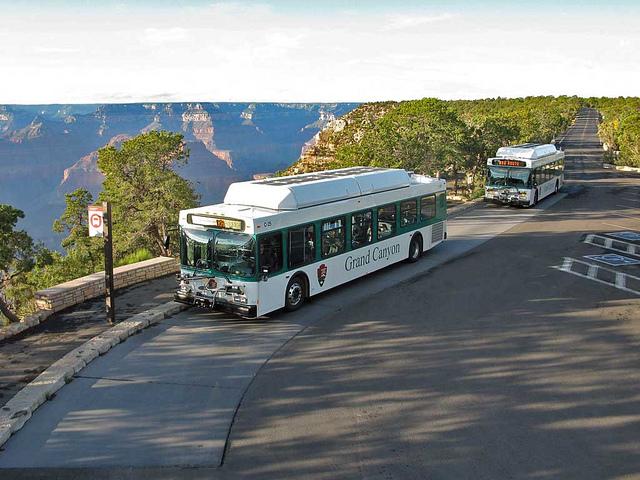Where is the Grand Canyon?
Concise answer only. Arizona. What color are the buses?
Give a very brief answer. White. How many buses are there?
Concise answer only. 2. What make and model bus is that?
Quick response, please. Grand canyon. 